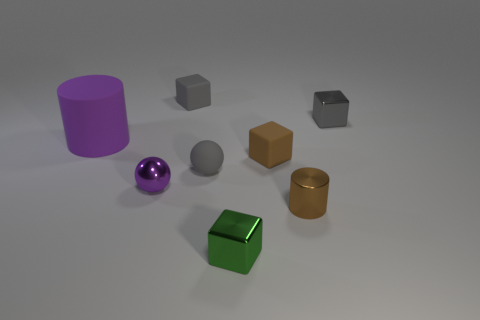Can you describe the texture of the green object on the ground? The green object on the ground has a smooth and glossy surface, reflecting the light in a way that gives it a polished appearance. 